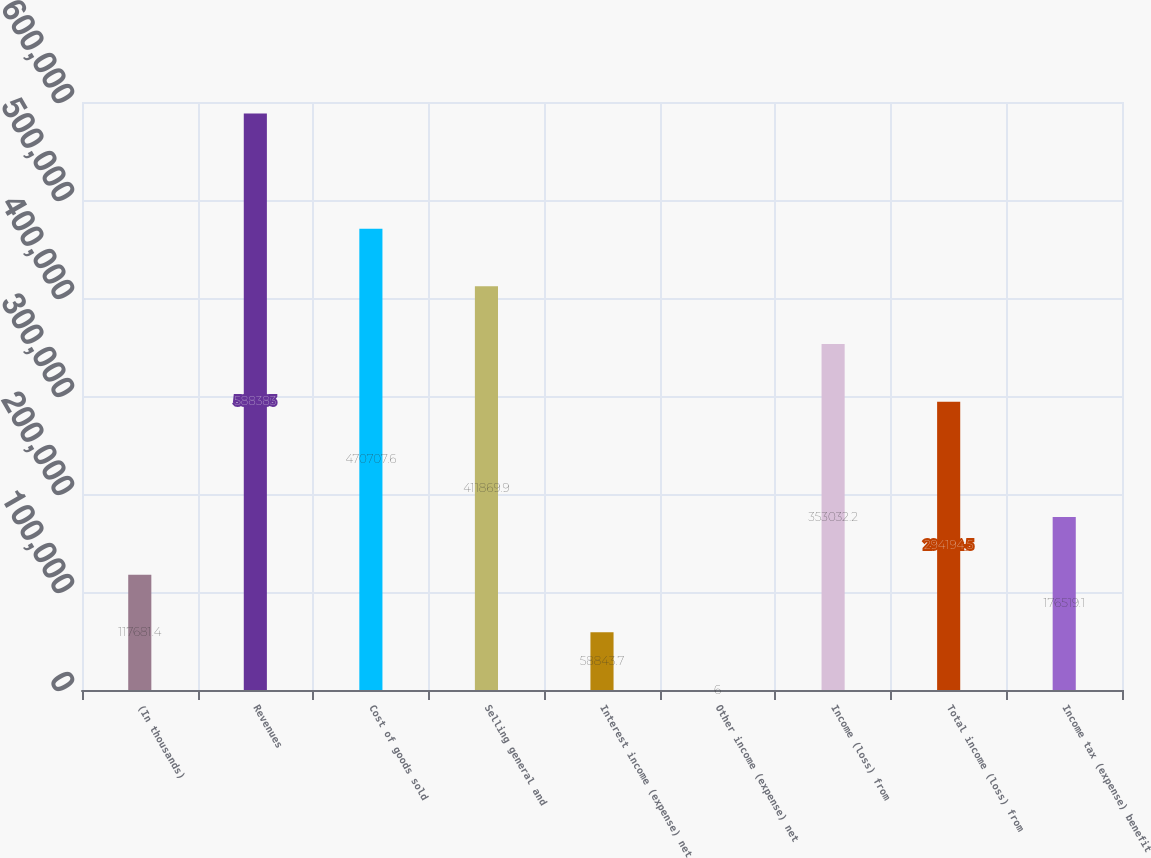Convert chart to OTSL. <chart><loc_0><loc_0><loc_500><loc_500><bar_chart><fcel>(In thousands)<fcel>Revenues<fcel>Cost of goods sold<fcel>Selling general and<fcel>Interest income (expense) net<fcel>Other income (expense) net<fcel>Income (loss) from<fcel>Total income (loss) from<fcel>Income tax (expense) benefit<nl><fcel>117681<fcel>588383<fcel>470708<fcel>411870<fcel>58843.7<fcel>6<fcel>353032<fcel>294194<fcel>176519<nl></chart> 